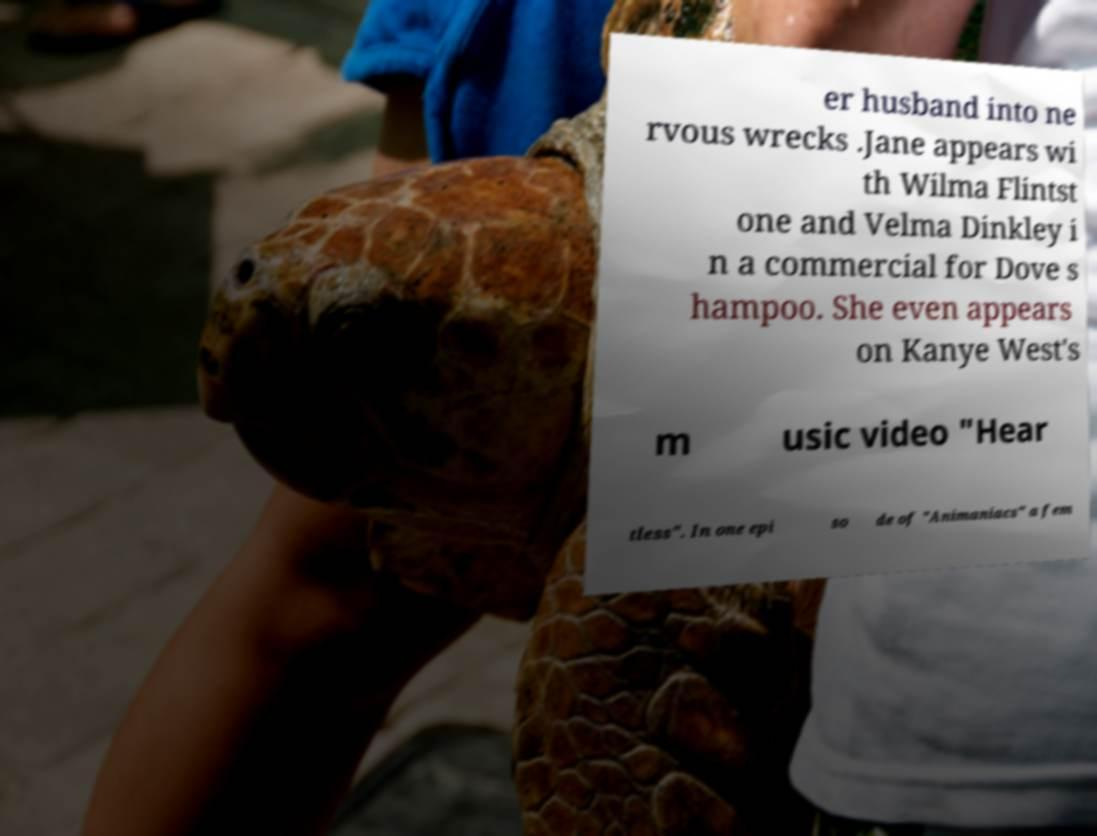What messages or text are displayed in this image? I need them in a readable, typed format. er husband into ne rvous wrecks .Jane appears wi th Wilma Flintst one and Velma Dinkley i n a commercial for Dove s hampoo. She even appears on Kanye West's m usic video "Hear tless". In one epi so de of "Animaniacs" a fem 